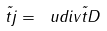<formula> <loc_0><loc_0><loc_500><loc_500>\vec { t } j = \ u d i v { \vec { t } D }</formula> 